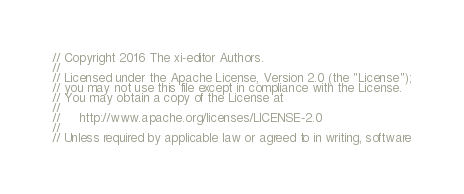Convert code to text. <code><loc_0><loc_0><loc_500><loc_500><_Rust_>// Copyright 2016 The xi-editor Authors.
//
// Licensed under the Apache License, Version 2.0 (the "License");
// you may not use this file except in compliance with the License.
// You may obtain a copy of the License at
//
//     http://www.apache.org/licenses/LICENSE-2.0
//
// Unless required by applicable law or agreed to in writing, software</code> 